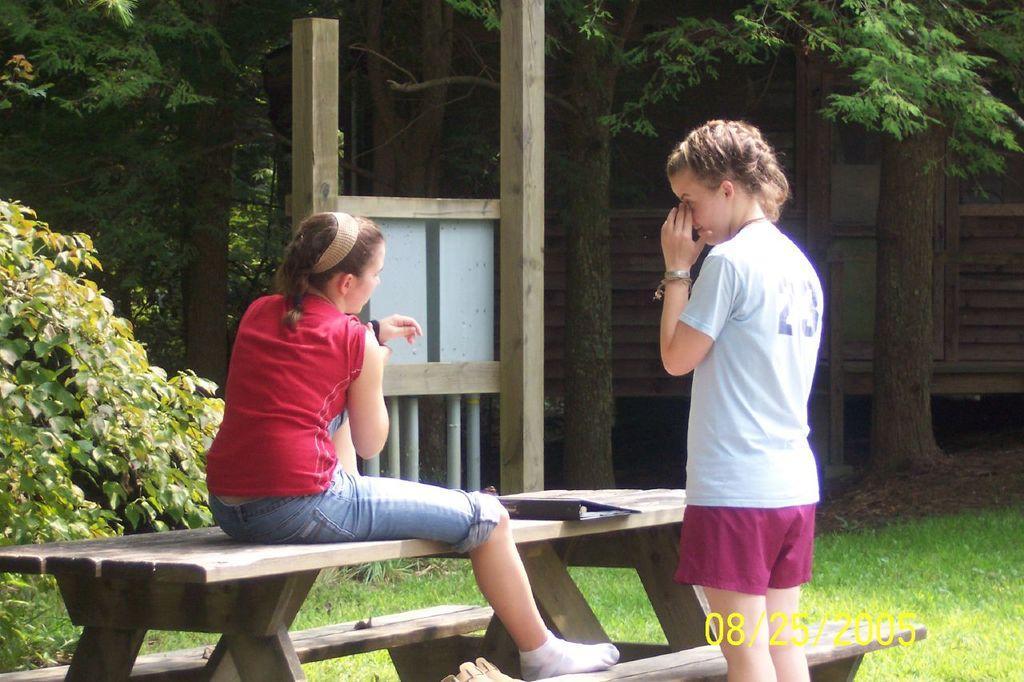Please provide a concise description of this image. This picture is taken outside. In this picture there are two girls, one girl sitting on the bench and another girl sitting beside it. In the background there is a tree and a plant. 